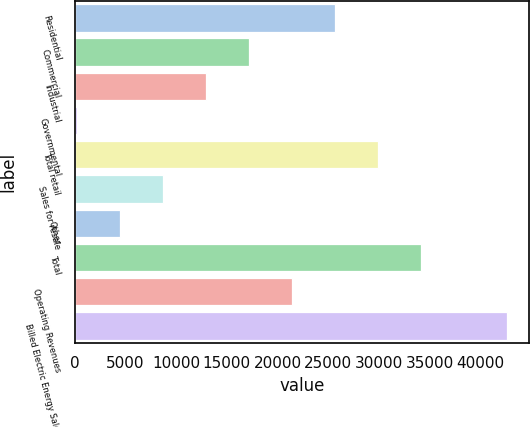Convert chart. <chart><loc_0><loc_0><loc_500><loc_500><bar_chart><fcel>Residential<fcel>Commercial<fcel>Industrial<fcel>Governmental<fcel>Total retail<fcel>Sales for resale<fcel>Other<fcel>Total<fcel>Operating Revenues<fcel>Billed Electric Energy Sales<nl><fcel>25694<fcel>17200<fcel>12953<fcel>212<fcel>29941<fcel>8706<fcel>4459<fcel>34188<fcel>21447<fcel>42682<nl></chart> 